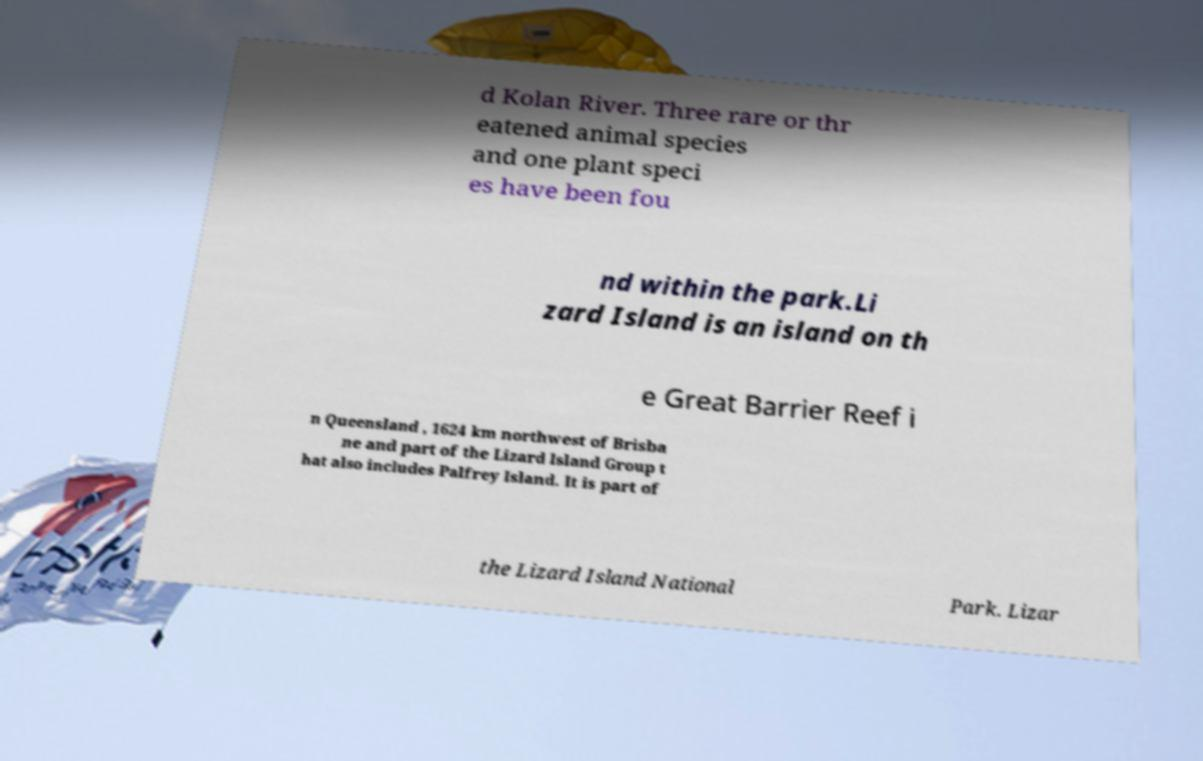I need the written content from this picture converted into text. Can you do that? d Kolan River. Three rare or thr eatened animal species and one plant speci es have been fou nd within the park.Li zard Island is an island on th e Great Barrier Reef i n Queensland , 1624 km northwest of Brisba ne and part of the Lizard Island Group t hat also includes Palfrey Island. It is part of the Lizard Island National Park. Lizar 